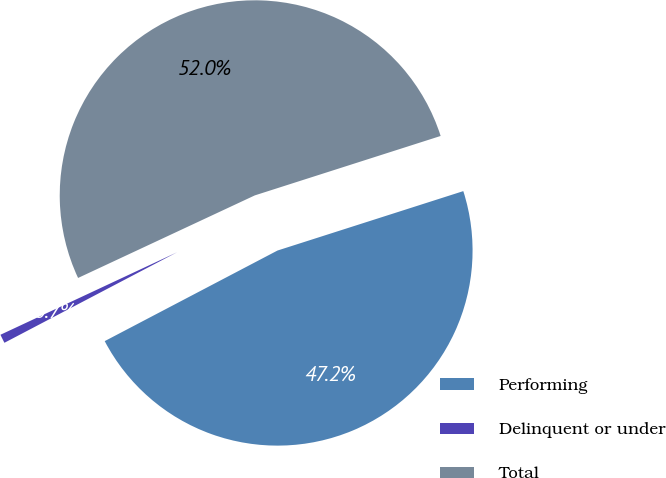Convert chart to OTSL. <chart><loc_0><loc_0><loc_500><loc_500><pie_chart><fcel>Performing<fcel>Delinquent or under<fcel>Total<nl><fcel>47.24%<fcel>0.73%<fcel>52.03%<nl></chart> 